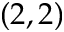<formula> <loc_0><loc_0><loc_500><loc_500>( 2 , 2 )</formula> 